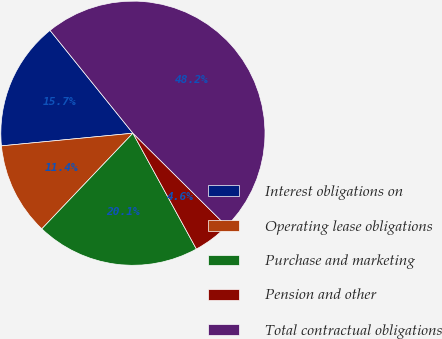Convert chart to OTSL. <chart><loc_0><loc_0><loc_500><loc_500><pie_chart><fcel>Interest obligations on<fcel>Operating lease obligations<fcel>Purchase and marketing<fcel>Pension and other<fcel>Total contractual obligations<nl><fcel>15.73%<fcel>11.36%<fcel>20.09%<fcel>4.58%<fcel>48.23%<nl></chart> 